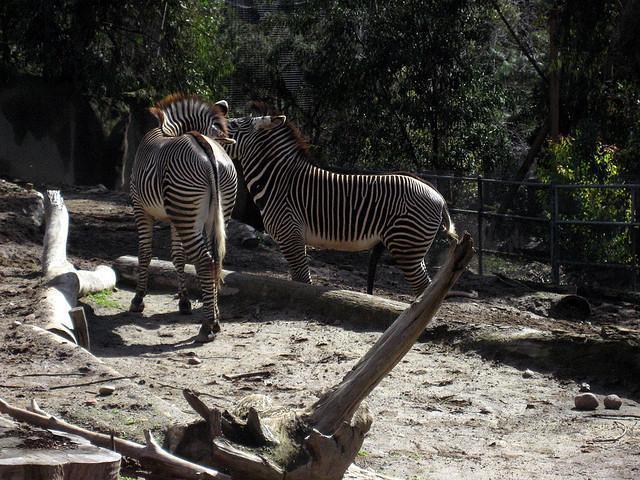How many zebras are in the picture?
Give a very brief answer. 2. 